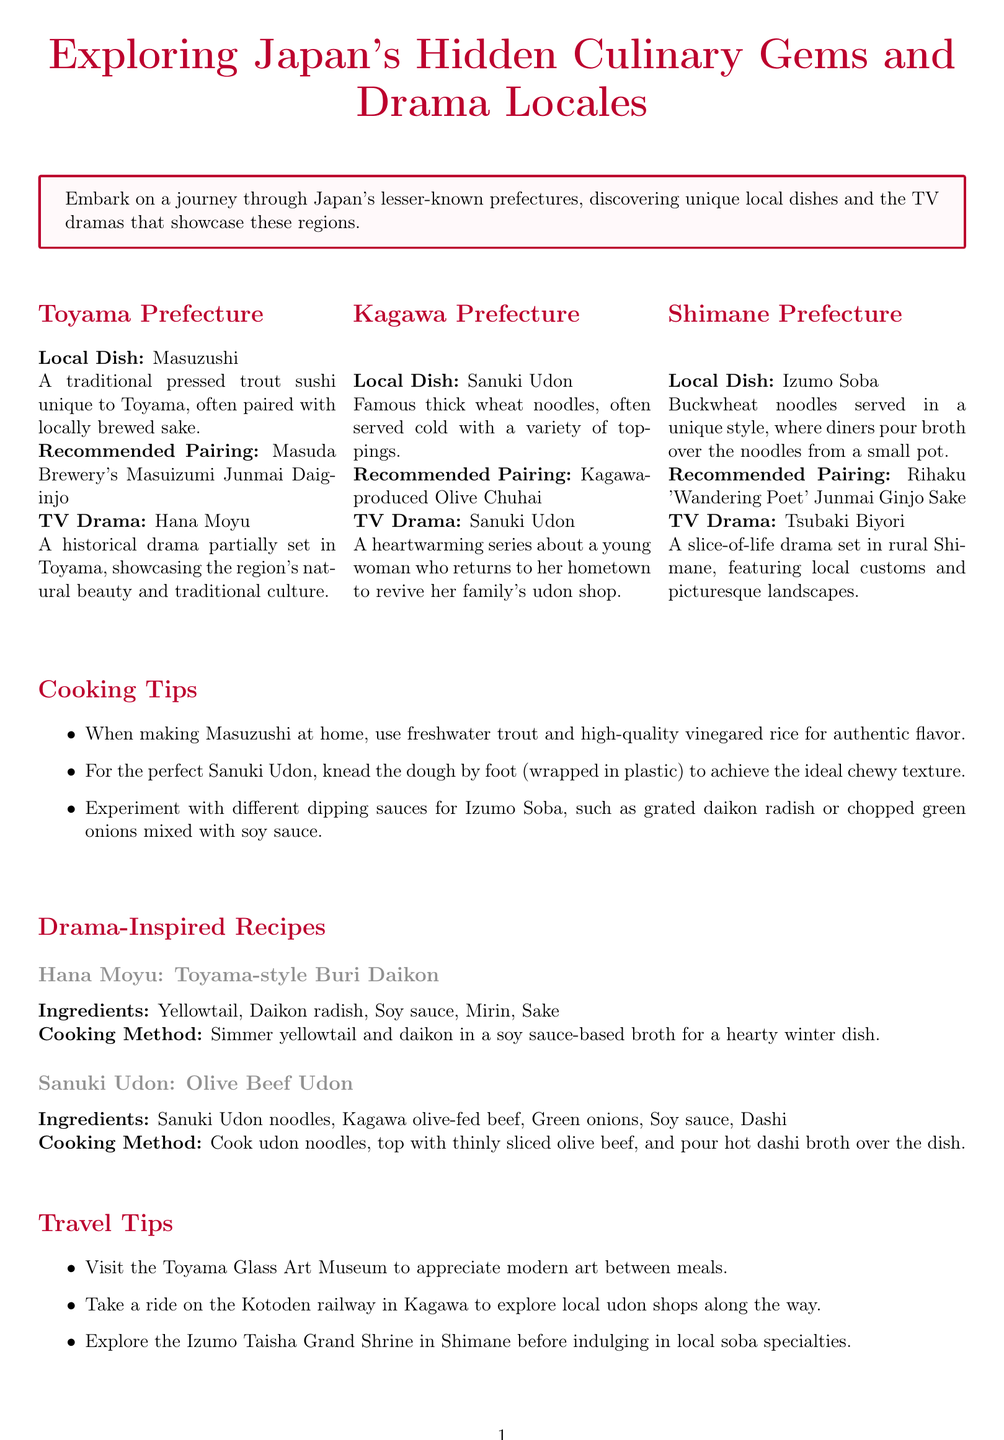What is Toyama's local dish? The local dish for Toyama Prefecture is specifically mentioned in the document as Masuzushi.
Answer: Masuzushi Which brewery is recommended for pairing with Masuzushi? The document recommends Masuda Brewery's Masuizumi Junmai Daiginjo for pairing with Masuzushi.
Answer: Masuda Brewery's Masuizumi Junmai Daiginjo What is the date of the Sanuki Udon Festival? The document states the Sanuki Udon Festival will take place from November 3-5, 2023.
Answer: November 3-5, 2023 What type of noodles are served in Izumo Soba? The document clearly describes Izumo Soba as buckwheat noodles.
Answer: Buckwheat noodles What drama is set in Kagawa Prefecture? The newsletter mentions the TV drama that takes place in Kagawa as Sanuki Udon.
Answer: Sanuki Udon Which local dish is associated with the drama Hana Moyu? The local dish associated with the drama Hana Moyu, as per the document, is Toyama-style Buri Daikon.
Answer: Toyama-style Buri Daikon What is one cooking tip for making Sanuki Udon? The document provides a specific tip about kneading the dough to achieve the ideal chewy texture for Sanuki Udon.
Answer: Knead the dough by foot What is a recommended activity in Shimane Prefecture before eating soba? According to the document, one should explore the Izumo Taisha Grand Shrine before indulging in local soba specialties.
Answer: Explore the Izumo Taisha Grand Shrine What are the ingredients for Olive Beef Udon? The document lists the ingredients for Olive Beef Udon as Sanuki Udon noodles, Kagawa olive-fed beef, green onions, soy sauce, and dashi.
Answer: Sanuki Udon noodles, Kagawa olive-fed beef, green onions, soy sauce, dashi 